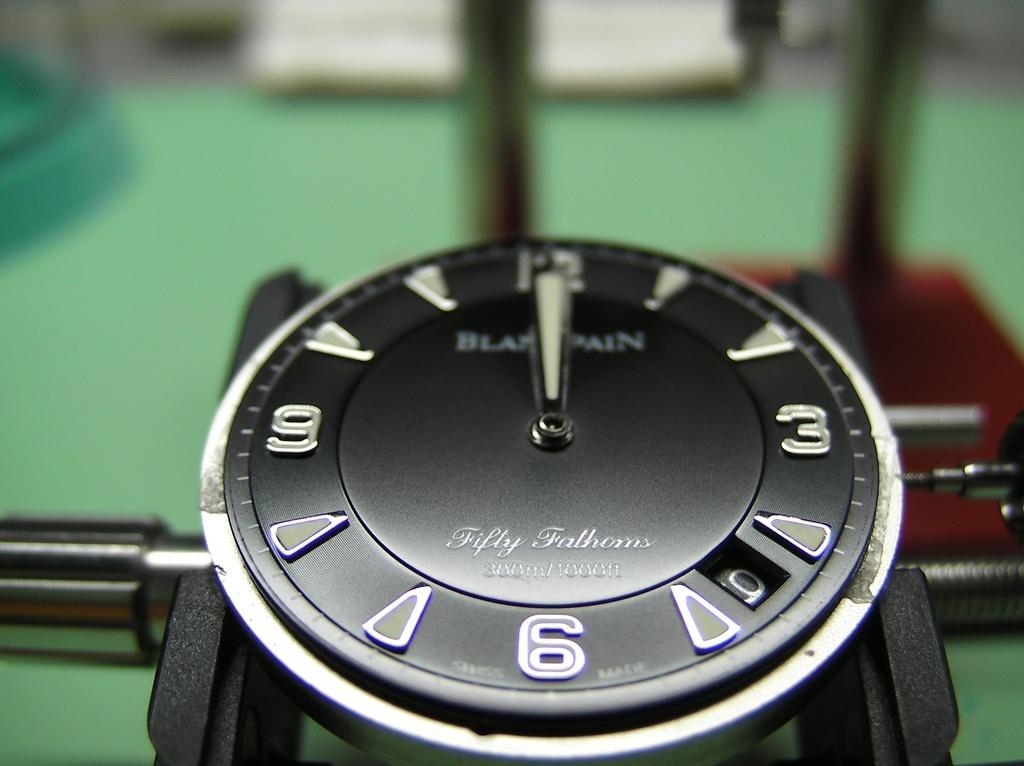Provide a one-sentence caption for the provided image. Black Fifty Fathoms 300 meter underwater Swiss watch. 